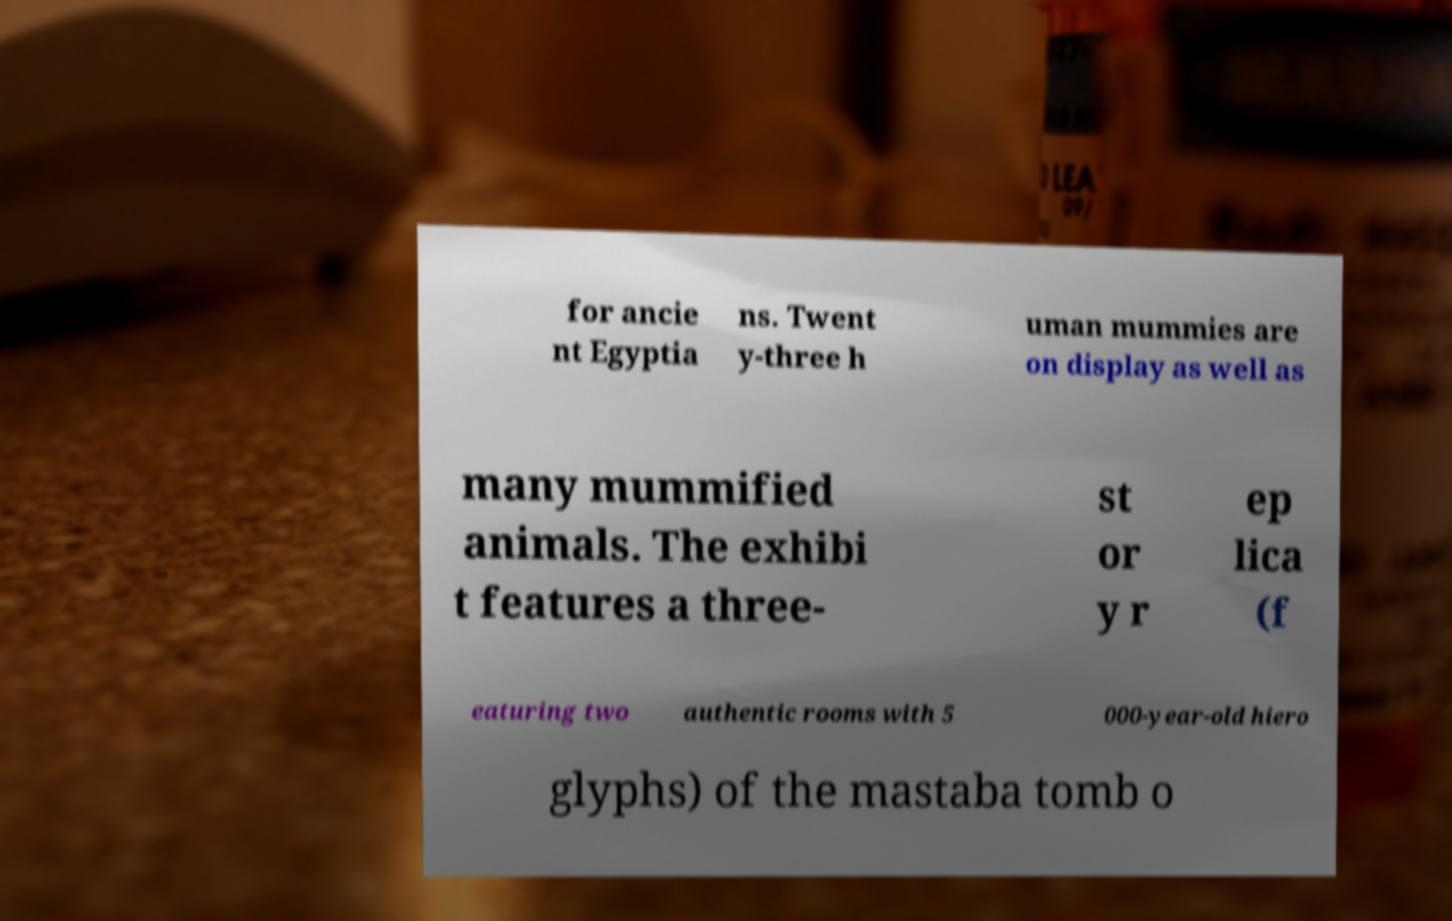I need the written content from this picture converted into text. Can you do that? for ancie nt Egyptia ns. Twent y-three h uman mummies are on display as well as many mummified animals. The exhibi t features a three- st or y r ep lica (f eaturing two authentic rooms with 5 000-year-old hiero glyphs) of the mastaba tomb o 